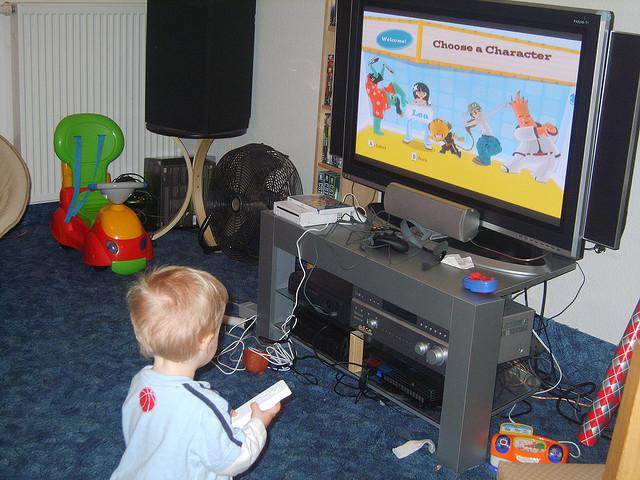Which character has been selected? lea 